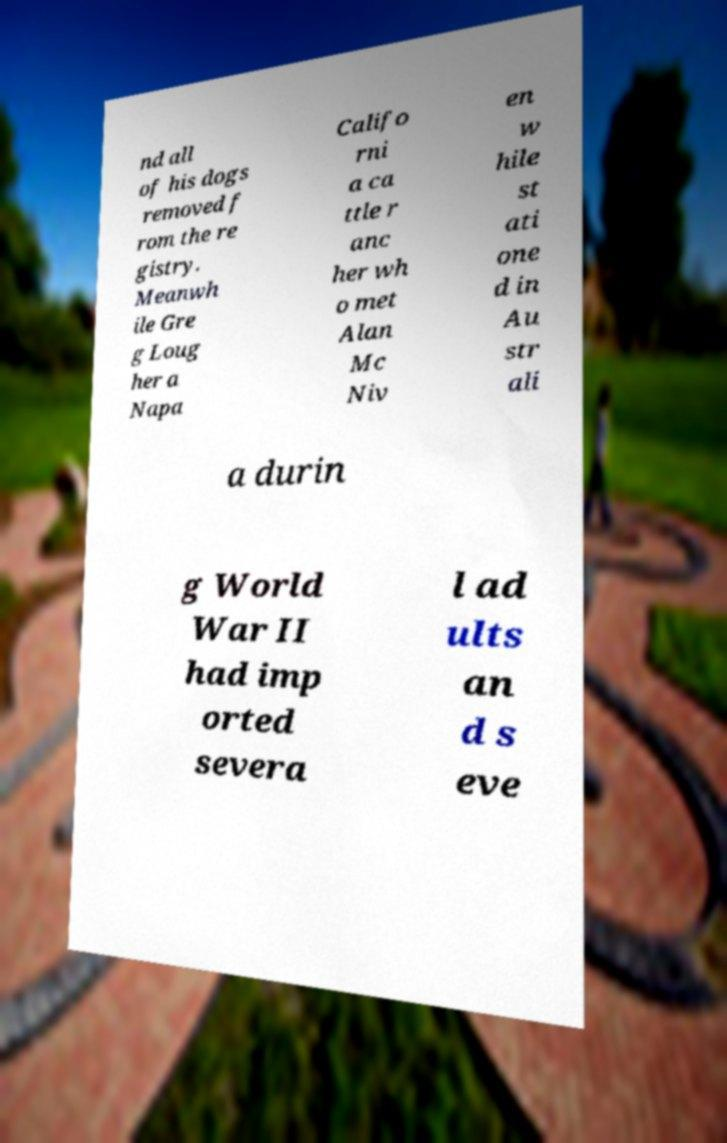Please read and relay the text visible in this image. What does it say? nd all of his dogs removed f rom the re gistry. Meanwh ile Gre g Loug her a Napa Califo rni a ca ttle r anc her wh o met Alan Mc Niv en w hile st ati one d in Au str ali a durin g World War II had imp orted severa l ad ults an d s eve 